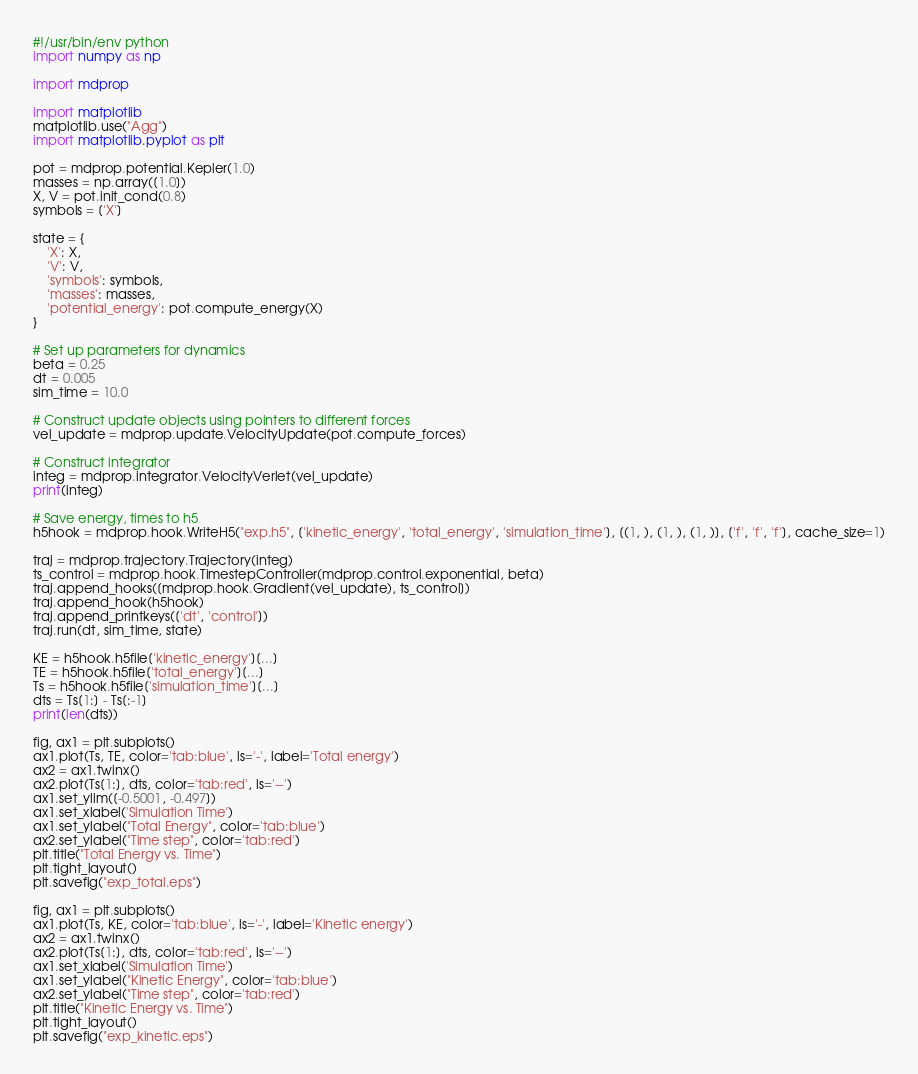Convert code to text. <code><loc_0><loc_0><loc_500><loc_500><_Python_>#!/usr/bin/env python
import numpy as np

import mdprop

import matplotlib
matplotlib.use("Agg")
import matplotlib.pyplot as plt

pot = mdprop.potential.Kepler(1.0)
masses = np.array([1.0])
X, V = pot.init_cond(0.8)
symbols = ['X']

state = {
    'X': X,
    'V': V,
    'symbols': symbols,
    'masses': masses,
    'potential_energy': pot.compute_energy(X)
}

# Set up parameters for dynamics
beta = 0.25
dt = 0.005
sim_time = 10.0

# Construct update objects using pointers to different forces
vel_update = mdprop.update.VelocityUpdate(pot.compute_forces)

# Construct integrator
integ = mdprop.integrator.VelocityVerlet(vel_update)
print(integ)

# Save energy, times to h5
h5hook = mdprop.hook.WriteH5("exp.h5", ['kinetic_energy', 'total_energy', 'simulation_time'], [(1, ), (1, ), (1, )], ['f', 'f', 'f'], cache_size=1)

traj = mdprop.trajectory.Trajectory(integ)
ts_control = mdprop.hook.TimestepController(mdprop.control.exponential, beta)
traj.append_hooks([mdprop.hook.Gradient(vel_update), ts_control])
traj.append_hook(h5hook)
traj.append_printkeys(['dt', 'control'])
traj.run(dt, sim_time, state)

KE = h5hook.h5file['kinetic_energy'][...]
TE = h5hook.h5file['total_energy'][...]
Ts = h5hook.h5file['simulation_time'][...]
dts = Ts[1:] - Ts[:-1]
print(len(dts))

fig, ax1 = plt.subplots()
ax1.plot(Ts, TE, color='tab:blue', ls='-', label='Total energy')
ax2 = ax1.twinx()
ax2.plot(Ts[1:], dts, color='tab:red', ls='--')
ax1.set_ylim([-0.5001, -0.497])
ax1.set_xlabel('Simulation Time')
ax1.set_ylabel("Total Energy", color='tab:blue')
ax2.set_ylabel("Time step", color='tab:red')
plt.title("Total Energy vs. Time")
plt.tight_layout()
plt.savefig("exp_total.eps")

fig, ax1 = plt.subplots()
ax1.plot(Ts, KE, color='tab:blue', ls='-', label='Kinetic energy')
ax2 = ax1.twinx()
ax2.plot(Ts[1:], dts, color='tab:red', ls='--')
ax1.set_xlabel('Simulation Time')
ax1.set_ylabel("Kinetic Energy", color='tab:blue')
ax2.set_ylabel("Time step", color='tab:red')
plt.title("Kinetic Energy vs. Time")
plt.tight_layout()
plt.savefig("exp_kinetic.eps")
</code> 